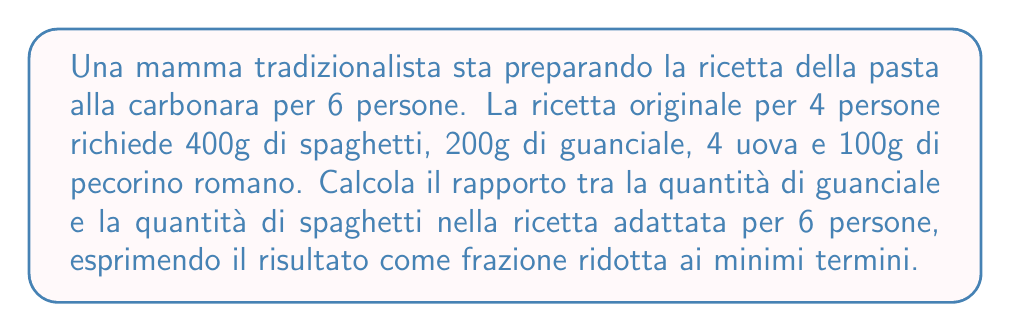Give your solution to this math problem. Per risolvere questo problema, seguiamo questi passaggi:

1) Prima, calcoliamo le quantità necessarie per 6 persone:

   Spaghetti: $400g \cdot \frac{6}{4} = 600g$
   Guanciale: $200g \cdot \frac{6}{4} = 300g$

2) Ora, dobbiamo calcolare il rapporto tra guanciale e spaghetti:

   $\frac{\text{Guanciale}}{\text{Spaghetti}} = \frac{300g}{600g}$

3) Semplifichiamo questa frazione:

   $\frac{300}{600} = \frac{300 \div 300}{600 \div 300} = \frac{1}{2}$

La frazione $\frac{1}{2}$ è già ridotta ai minimi termini, quindi questa è la nostra risposta finale.
Answer: $\frac{1}{2}$ 